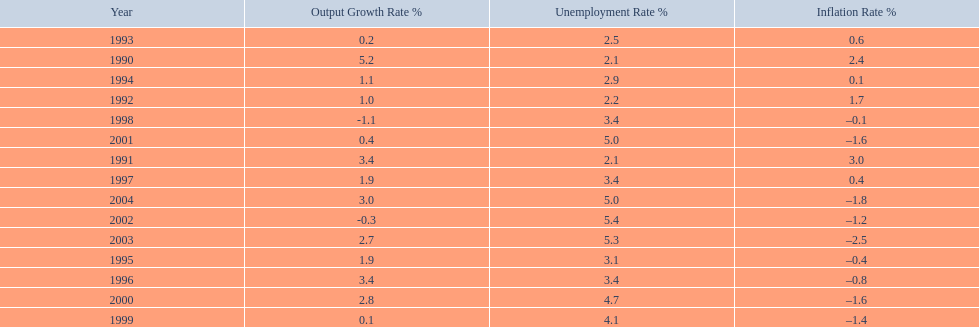In what years, between 1990 and 2004, did japan's unemployment rate reach 5% or higher? 4. 